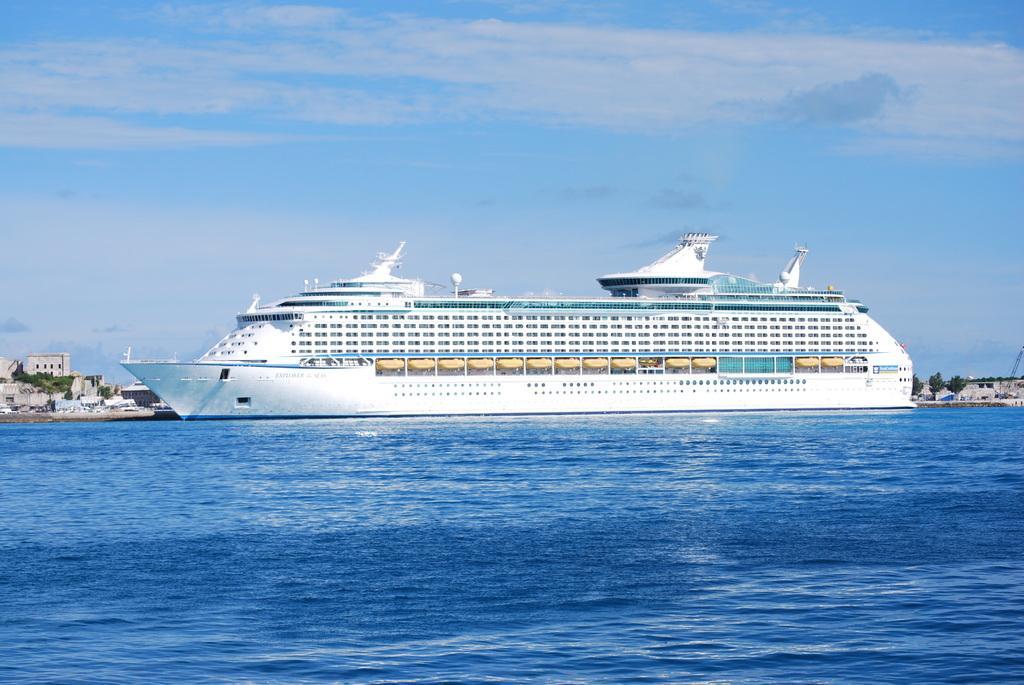What is the main subject in the foreground of the image? There is a ship in the water in the foreground of the image. What can be seen in the background of the image? There are trees and buildings in the background of the image. What is visible at the top of the image? The sky is visible at the top of the image. What can be observed in the sky? There are clouds in the sky. Where is the throne located in the image? There is no throne present in the image. What type of muscle can be seen flexing in the image? There are no muscles visible in the image, as it features a ship in the water, trees, buildings, and clouds. 